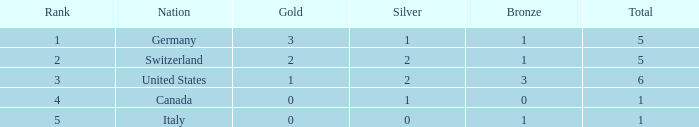What is the number of gold medals for countries with more than 0 silver medals, over 1 total medal, and more than 3 bronze medals? 0.0. 